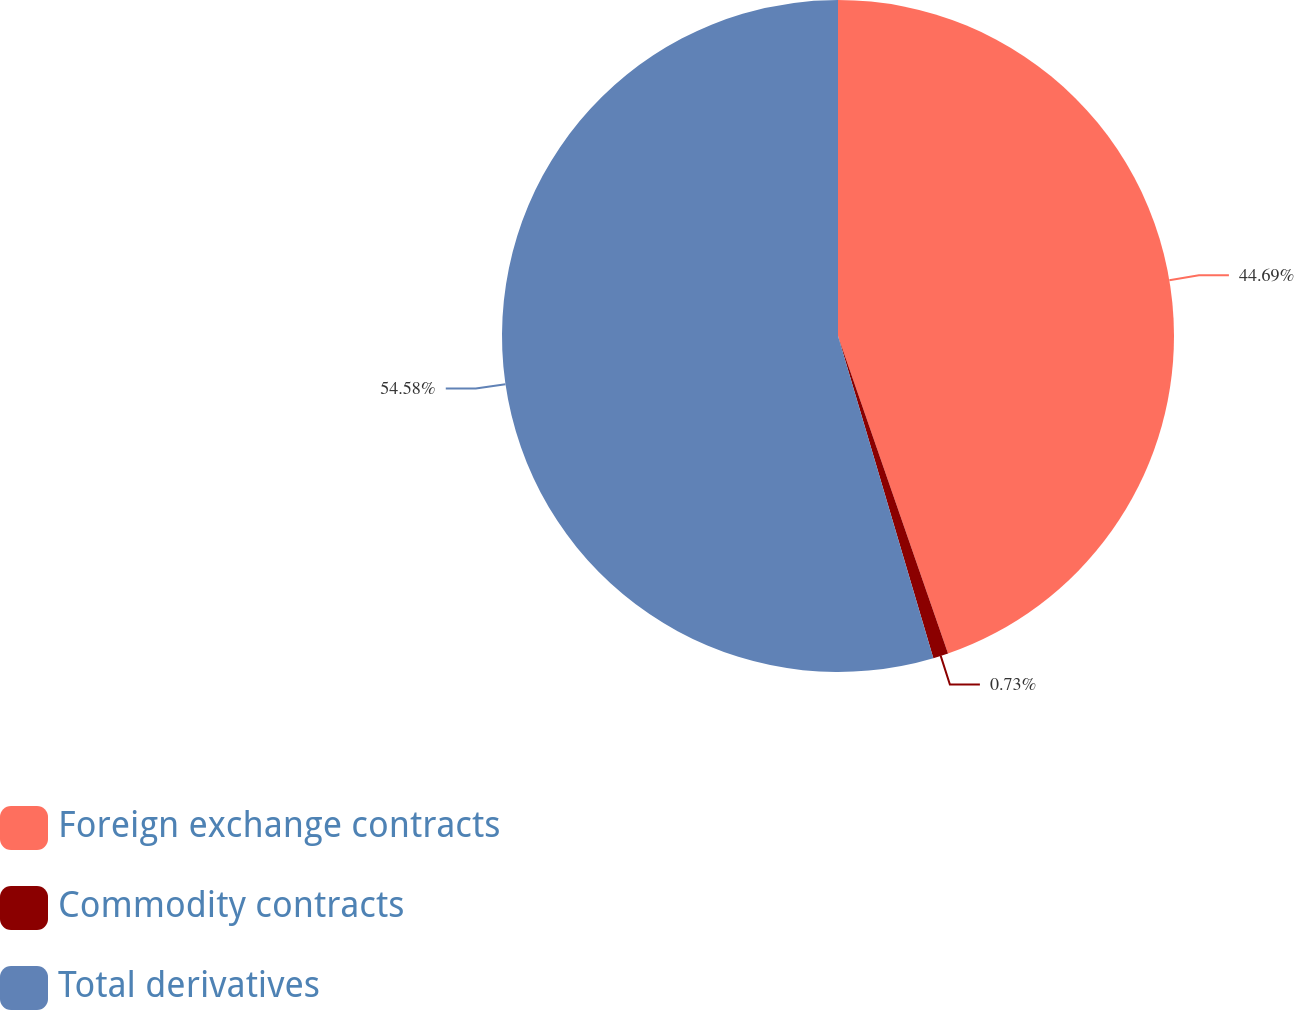Convert chart to OTSL. <chart><loc_0><loc_0><loc_500><loc_500><pie_chart><fcel>Foreign exchange contracts<fcel>Commodity contracts<fcel>Total derivatives<nl><fcel>44.69%<fcel>0.73%<fcel>54.58%<nl></chart> 